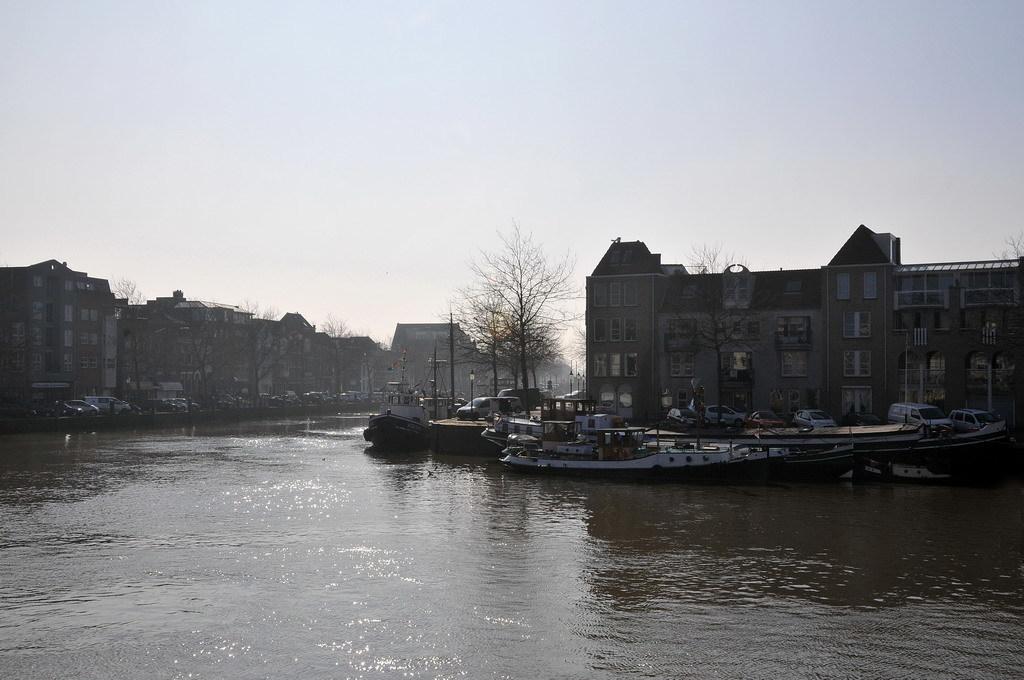Can you describe this image briefly? In this image, there are a few boats sailing on the water. We can see some buildings, trees, poles, vehicles. We can also see the ground and the sky. 